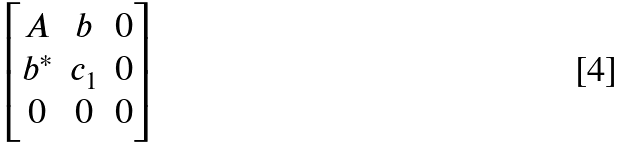Convert formula to latex. <formula><loc_0><loc_0><loc_500><loc_500>\begin{bmatrix} A & b & 0 \\ b ^ { * } & c _ { 1 } & 0 \\ 0 & 0 & 0 \end{bmatrix}</formula> 